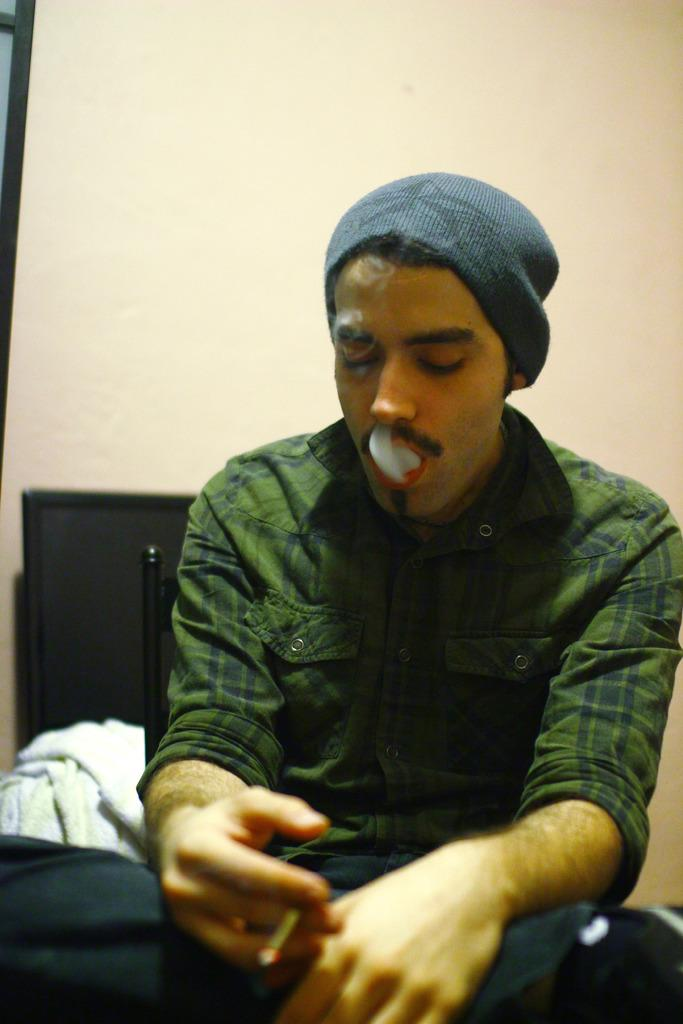What is the man in the image doing? The man is seated in the image. What is the man holding in his hand? The man is holding a cigarette in his hand. What is on the man's head? The man is wearing a cap on his head. What can be seen in the image that might indicate the presence of smoke? There is smoke visible in the image. What type of electronic device can be seen in the image? There appears to be a television in the image. What is visible in the background of the image? There is a wall visible in the background of the image. What type of steel is being used to construct the cub in the image? There is no cub present in the image, and therefore no steel can be observed. 